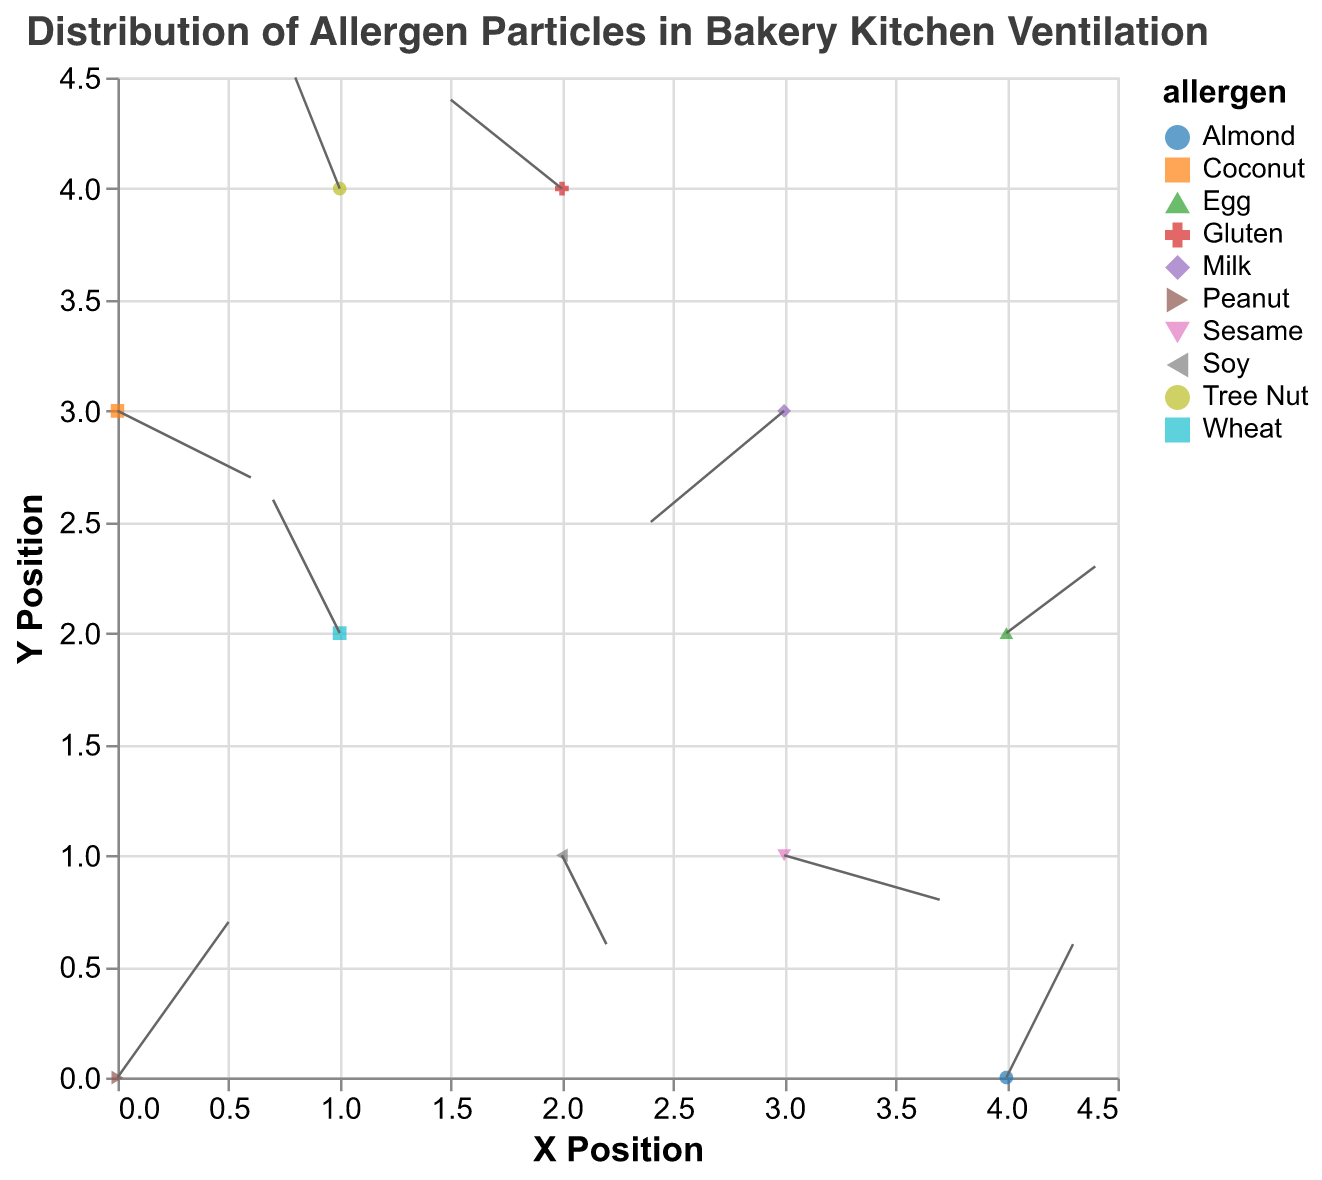what does the title "Distribution of Allergen Particles in Bakery Kitchen Ventilation" tell us about the plot? The title informs us that the plot displays the distribution of various allergen particles within the bakery's kitchen ventilation system.
Answer: Distribution of allergen particles How many different allergens are represented in the plot? By observing the different colors and shapes corresponding to each allergen on the plot, we can count a total of 10 distinct allergens.
Answer: 10 What allergens are found at the point (0, 0)? By looking at the plot, we identify the point (0, 0) and check the associated label/color. According to the data, Peanut allergens are found at this point.
Answer: Peanut Which allergen particles have a purely horizontal direction (either left or right without vertical movement)? We look for allergen particles with v=0. By checking each vector (u, v), we find that none of the particles have a purely horizontal direction.
Answer: None What allergen particles show negative horizontal movement? Negative horizontal movement corresponds to u < 0. In the data, Wheat (-0.3), Milk (-0.6), Tree Nut (-0.2), and Gluten (-0.5) show negative horizontal movement.
Answer: Wheat, Milk, Tree Nut, Gluten Comparing Peanut and Coconut particles, which one has a larger vertical vector component? By checking the vectors, Peanut has a vertical component of 0.7, while Coconut has -0.3. Thus, Peanut has a larger vertical component.
Answer: Peanut What is the combined horizontal displacement (sum of u values) for all allergens? Summing up all u values: 0.5 + (-0.3) + 0.2 + (-0.6) + 0.4 + (-0.2) + 0.7 + (-0.5) + 0.3 + 0.6 = 1.1
Answer: 1.1 Considering both horizontal (u) and vertical (v) directions, which allergen has the overall largest vector magnitude? Calculate vector magnitude for each allergen using sqrt(u^2 + v^2). Largest value calculation: sqrt(0.5^2 + 0.7^2) = 0.86 (Peanut).
Answer: Peanut What allergen is located at the highest y-coordinate? Checking each allergen's y-coordinate, the highest is y=4. Both Tree Nut and Gluten are at this y-coordinate, but Tree Nut is at y=4.
Answer: Tree Nut How would you describe the airflow direction of Sesame compared to Soy? Comparing the vectors of Sesame (0.7, -0.2) and Soy (0.2, -0.4), Sesame has a stronger rightward direction and slight downward, while Soy has a slight rightward and larger downward direction.
Answer: Sesame is more rightward, slightly down; Soy is slightly rightward, more downward 